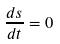Convert formula to latex. <formula><loc_0><loc_0><loc_500><loc_500>\frac { d s } { d t } = 0</formula> 